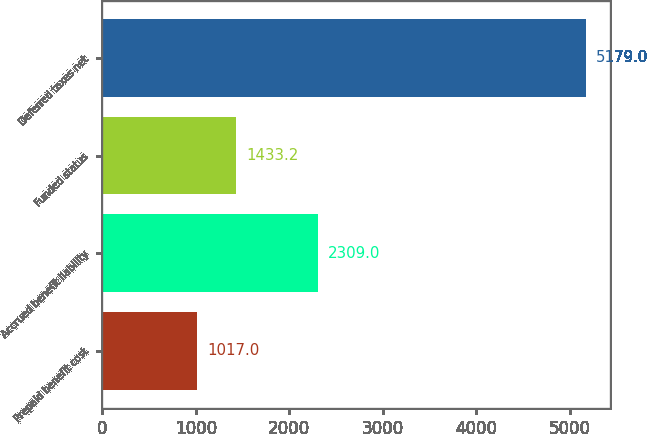Convert chart to OTSL. <chart><loc_0><loc_0><loc_500><loc_500><bar_chart><fcel>Prepaid benefit cost<fcel>Accrued benefit liability<fcel>Funded status<fcel>Deferred taxes net<nl><fcel>1017<fcel>2309<fcel>1433.2<fcel>5179<nl></chart> 